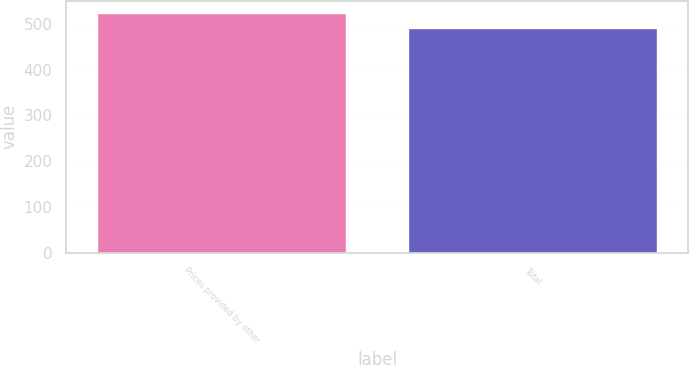Convert chart to OTSL. <chart><loc_0><loc_0><loc_500><loc_500><bar_chart><fcel>Prices provided by other<fcel>Total<nl><fcel>525<fcel>492<nl></chart> 